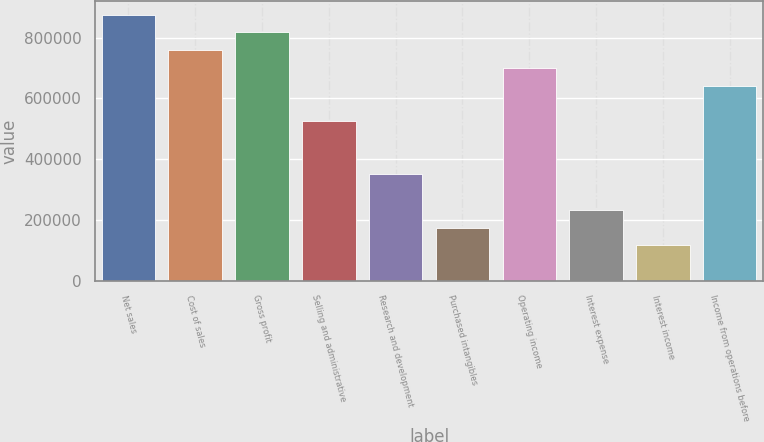Convert chart to OTSL. <chart><loc_0><loc_0><loc_500><loc_500><bar_chart><fcel>Net sales<fcel>Cost of sales<fcel>Gross profit<fcel>Selling and administrative<fcel>Research and development<fcel>Purchased intangibles<fcel>Operating income<fcel>Interest expense<fcel>Interest income<fcel>Income from operations before<nl><fcel>875804<fcel>759030<fcel>817417<fcel>525483<fcel>350323<fcel>175162<fcel>700644<fcel>233549<fcel>116775<fcel>642257<nl></chart> 